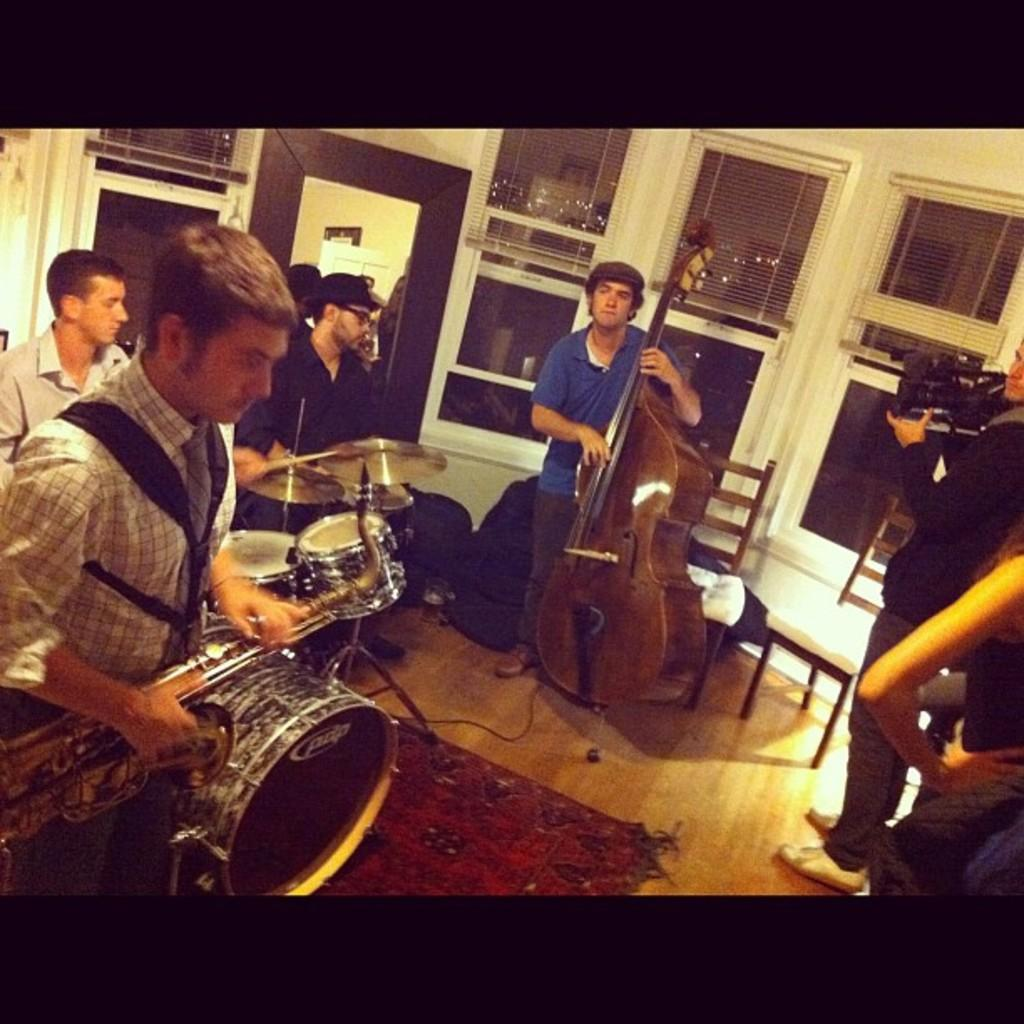What is happening in the image? There are people in the image, and some of them are holding musical instruments. Can you describe the setting of the image? There are chairs and a mirror in the background of the image. What type of produce is being harvested by the beginner in the image? There is no produce or beginner present in the image; it features people holding musical instruments. 